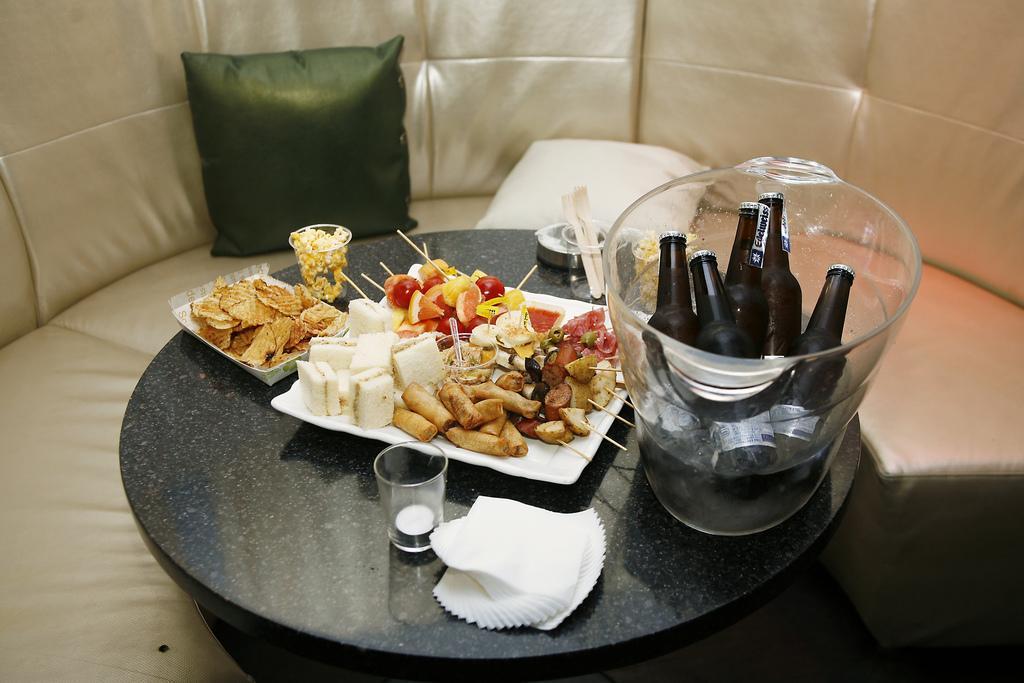How would you summarize this image in a sentence or two? In this image there is a food, bread in plate , pop corn in glass , chips in plate, tissues, glass, drinks in a glass jar , spoons in a glass , arranged in a table and in back ground there is a couch and 2 pillows. 